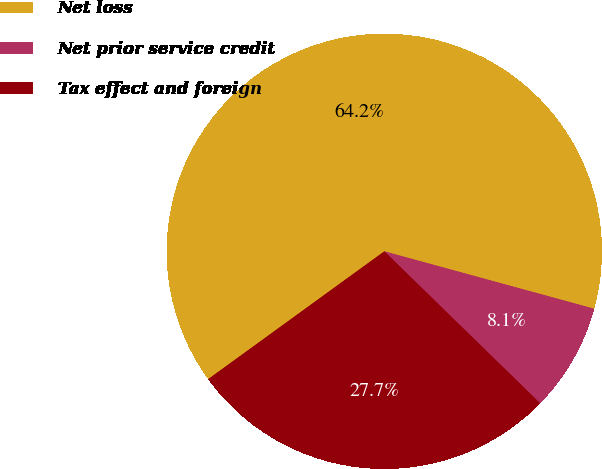<chart> <loc_0><loc_0><loc_500><loc_500><pie_chart><fcel>Net loss<fcel>Net prior service credit<fcel>Tax effect and foreign<nl><fcel>64.24%<fcel>8.05%<fcel>27.71%<nl></chart> 